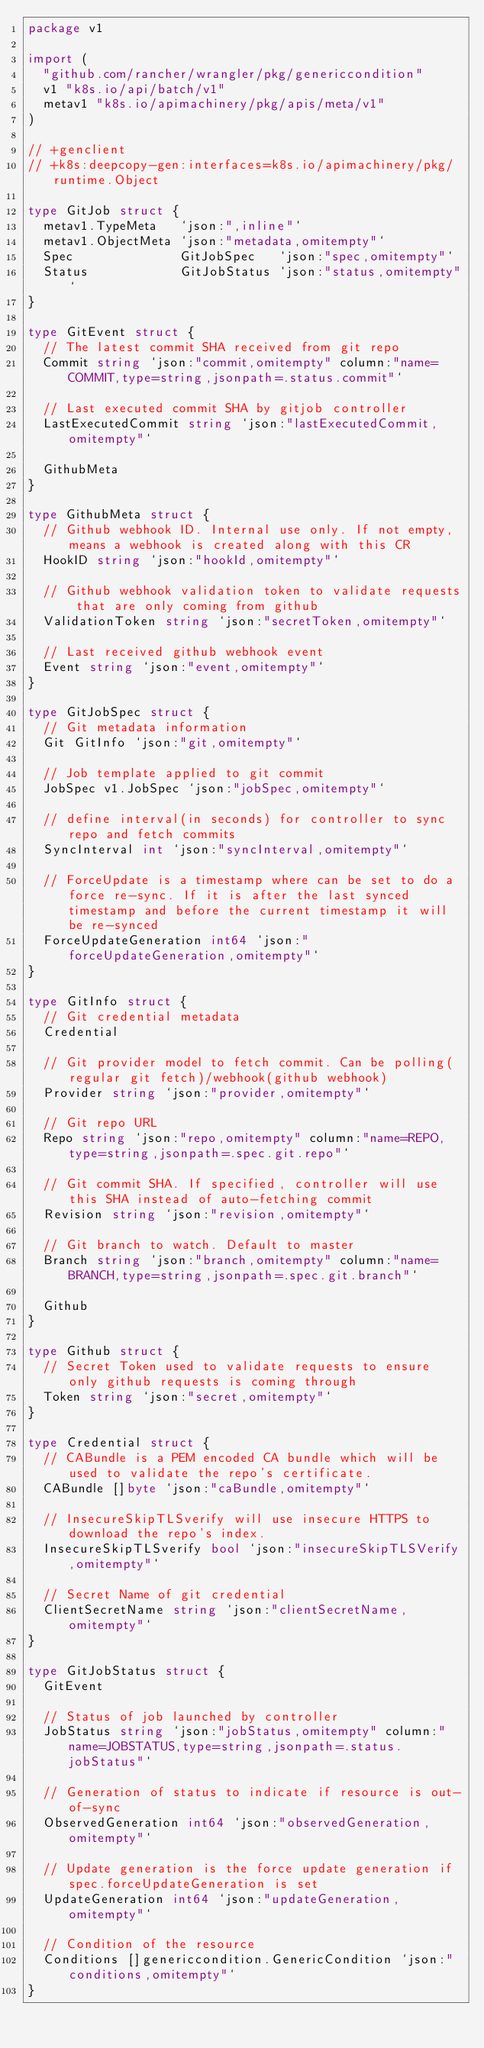Convert code to text. <code><loc_0><loc_0><loc_500><loc_500><_Go_>package v1

import (
	"github.com/rancher/wrangler/pkg/genericcondition"
	v1 "k8s.io/api/batch/v1"
	metav1 "k8s.io/apimachinery/pkg/apis/meta/v1"
)

// +genclient
// +k8s:deepcopy-gen:interfaces=k8s.io/apimachinery/pkg/runtime.Object

type GitJob struct {
	metav1.TypeMeta   `json:",inline"`
	metav1.ObjectMeta `json:"metadata,omitempty"`
	Spec              GitJobSpec   `json:"spec,omitempty"`
	Status            GitJobStatus `json:"status,omitempty"`
}

type GitEvent struct {
	// The latest commit SHA received from git repo
	Commit string `json:"commit,omitempty" column:"name=COMMIT,type=string,jsonpath=.status.commit"`

	// Last executed commit SHA by gitjob controller
	LastExecutedCommit string `json:"lastExecutedCommit,omitempty"`

	GithubMeta
}

type GithubMeta struct {
	// Github webhook ID. Internal use only. If not empty, means a webhook is created along with this CR
	HookID string `json:"hookId,omitempty"`

	// Github webhook validation token to validate requests that are only coming from github
	ValidationToken string `json:"secretToken,omitempty"`

	// Last received github webhook event
	Event string `json:"event,omitempty"`
}

type GitJobSpec struct {
	// Git metadata information
	Git GitInfo `json:"git,omitempty"`

	// Job template applied to git commit
	JobSpec v1.JobSpec `json:"jobSpec,omitempty"`

	// define interval(in seconds) for controller to sync repo and fetch commits
	SyncInterval int `json:"syncInterval,omitempty"`

	// ForceUpdate is a timestamp where can be set to do a force re-sync. If it is after the last synced timestamp and before the current timestamp it will be re-synced
	ForceUpdateGeneration int64 `json:"forceUpdateGeneration,omitempty"`
}

type GitInfo struct {
	// Git credential metadata
	Credential

	// Git provider model to fetch commit. Can be polling(regular git fetch)/webhook(github webhook)
	Provider string `json:"provider,omitempty"`

	// Git repo URL
	Repo string `json:"repo,omitempty" column:"name=REPO,type=string,jsonpath=.spec.git.repo"`

	// Git commit SHA. If specified, controller will use this SHA instead of auto-fetching commit
	Revision string `json:"revision,omitempty"`

	// Git branch to watch. Default to master
	Branch string `json:"branch,omitempty" column:"name=BRANCH,type=string,jsonpath=.spec.git.branch"`

	Github
}

type Github struct {
	// Secret Token used to validate requests to ensure only github requests is coming through
	Token string `json:"secret,omitempty"`
}

type Credential struct {
	// CABundle is a PEM encoded CA bundle which will be used to validate the repo's certificate.
	CABundle []byte `json:"caBundle,omitempty"`

	// InsecureSkipTLSverify will use insecure HTTPS to download the repo's index.
	InsecureSkipTLSverify bool `json:"insecureSkipTLSVerify,omitempty"`

	// Secret Name of git credential
	ClientSecretName string `json:"clientSecretName,omitempty"`
}

type GitJobStatus struct {
	GitEvent

	// Status of job launched by controller
	JobStatus string `json:"jobStatus,omitempty" column:"name=JOBSTATUS,type=string,jsonpath=.status.jobStatus"`

	// Generation of status to indicate if resource is out-of-sync
	ObservedGeneration int64 `json:"observedGeneration,omitempty"`

	// Update generation is the force update generation if spec.forceUpdateGeneration is set
	UpdateGeneration int64 `json:"updateGeneration,omitempty"`

	// Condition of the resource
	Conditions []genericcondition.GenericCondition `json:"conditions,omitempty"`
}
</code> 